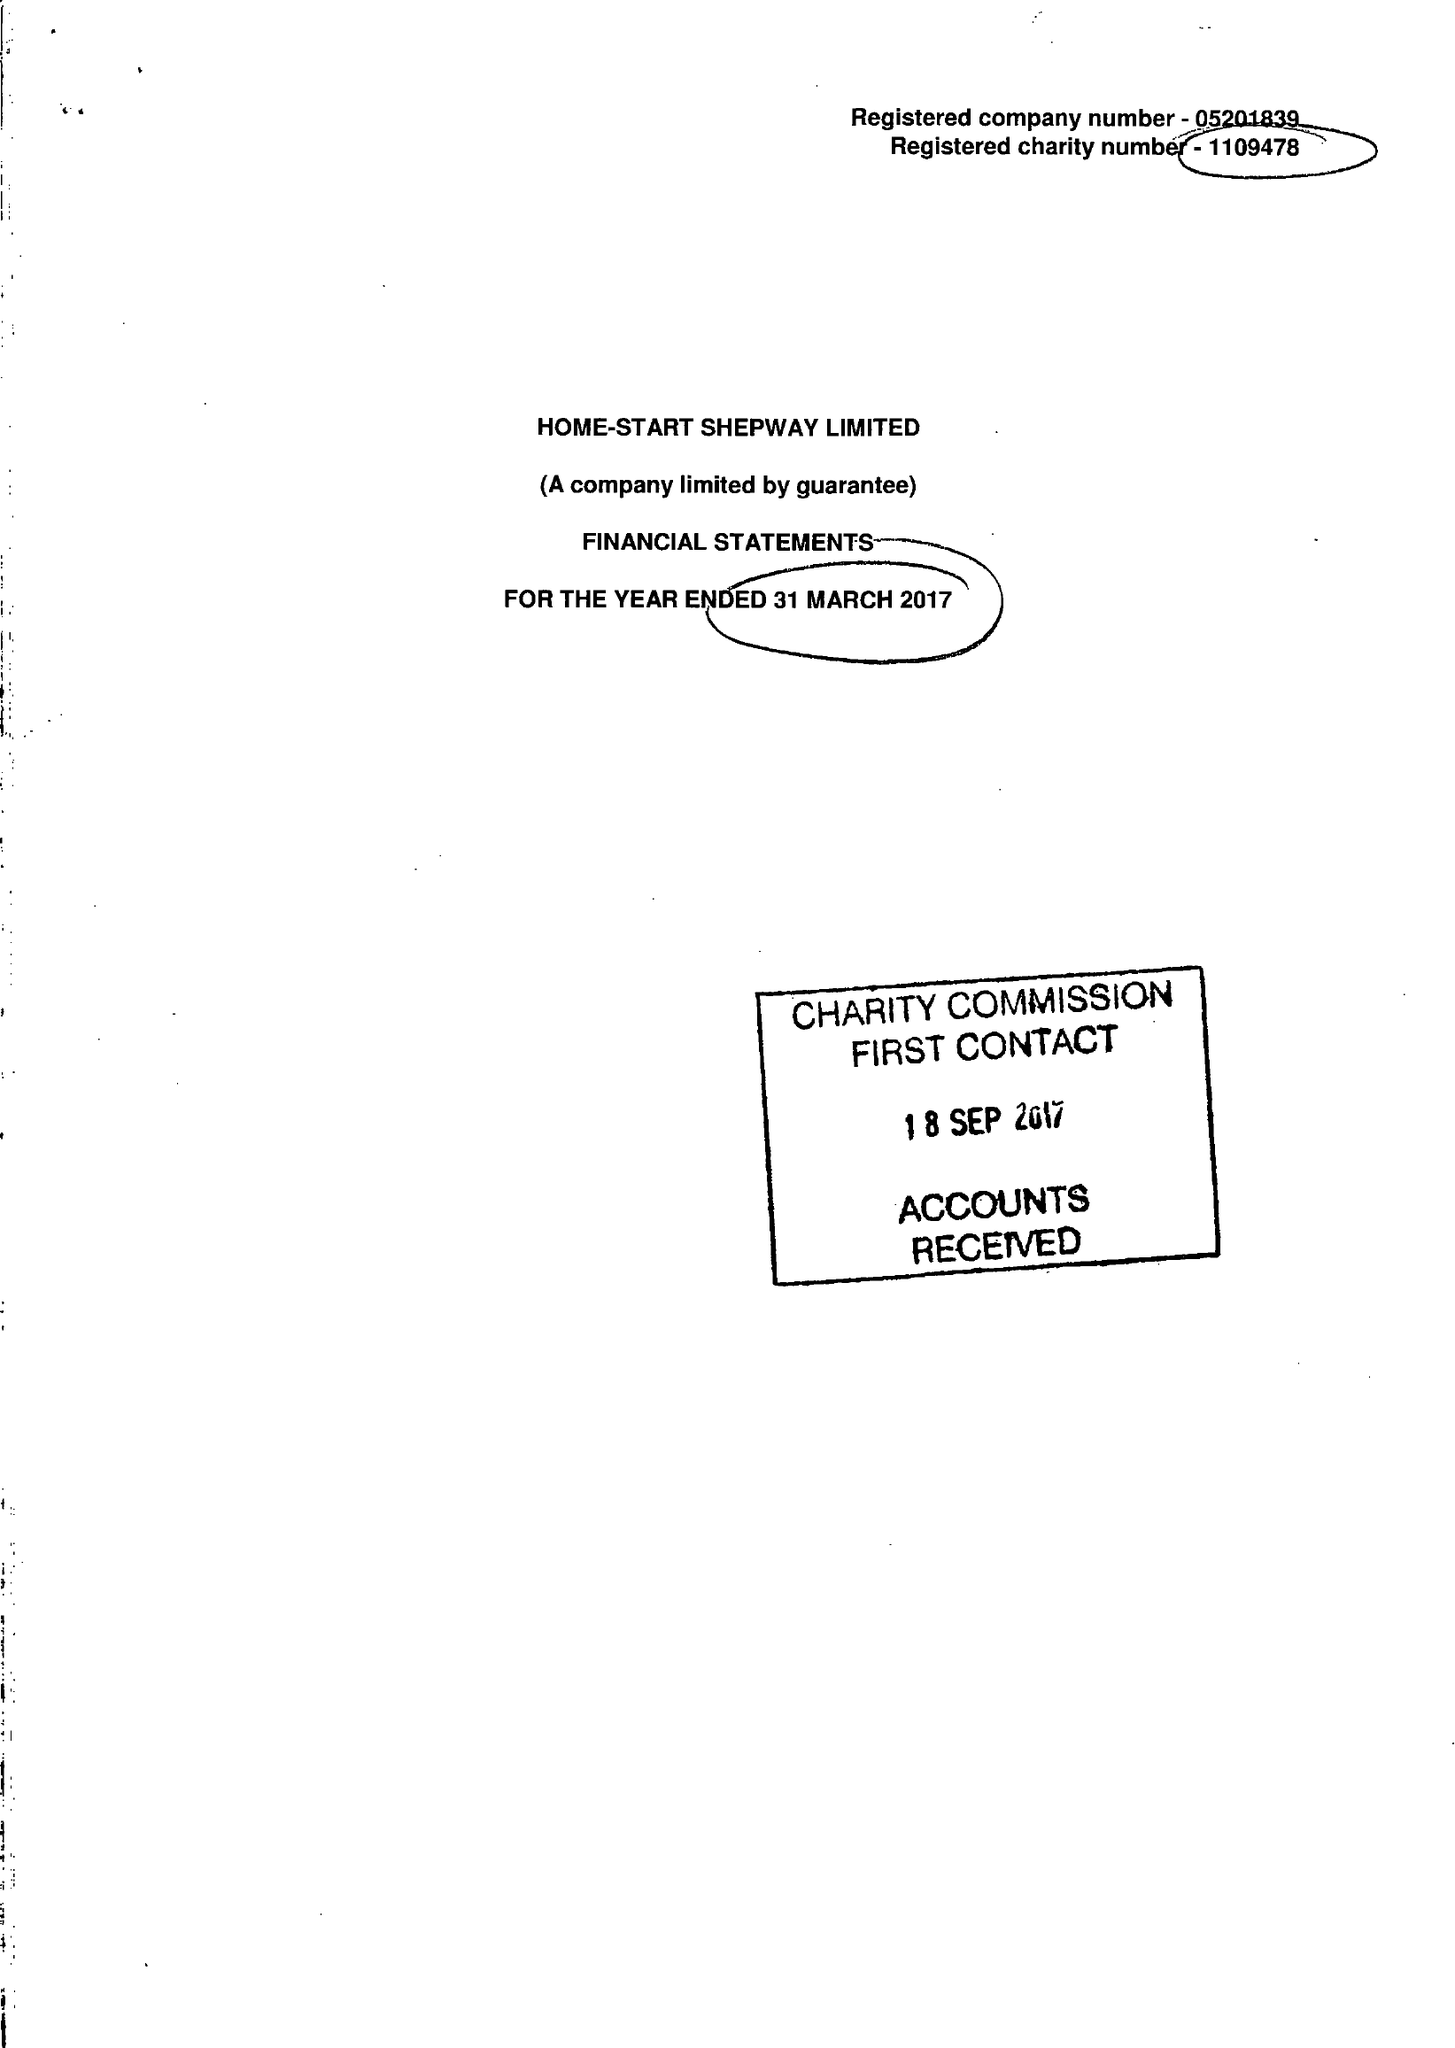What is the value for the address__street_line?
Answer the question using a single word or phrase. 24 CHERITON GARDENS 